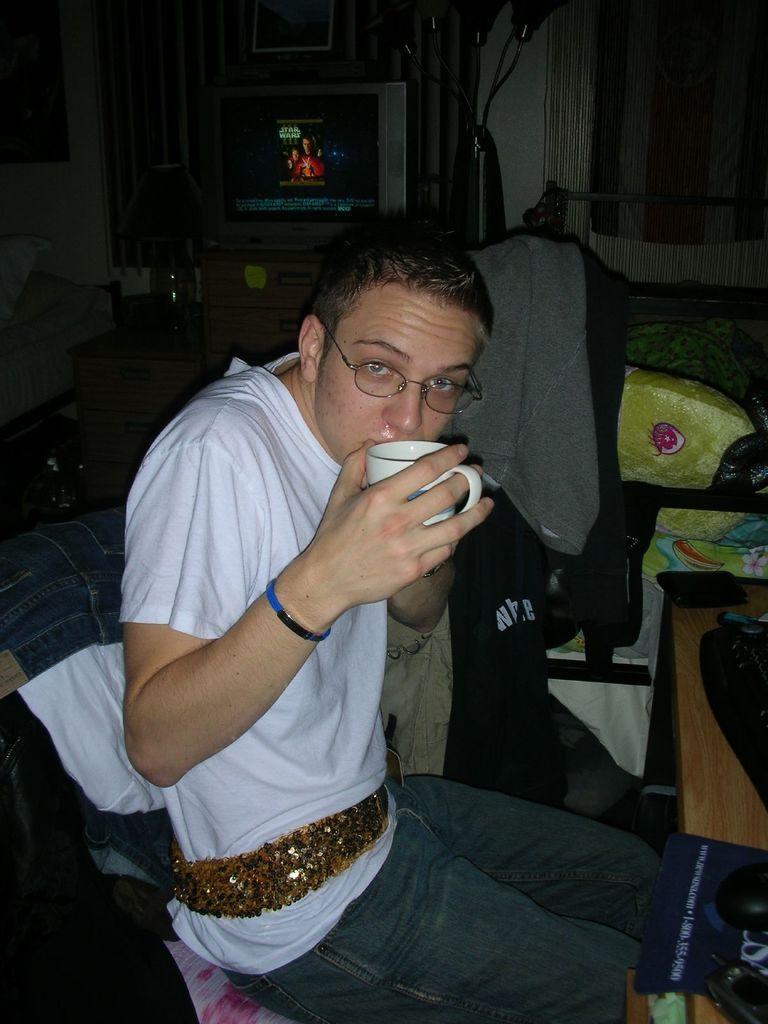Could you give a brief overview of what you see in this image? There is a man sitting and wore spectacle and holding a cup,in front of him we can see mouse,mouse pad,keyboard and objects on the table and we can see clothes. In the background we can see television and lamp on cupboards,beside television we can see an object. We can see frame,curtain,pillows and wall. 